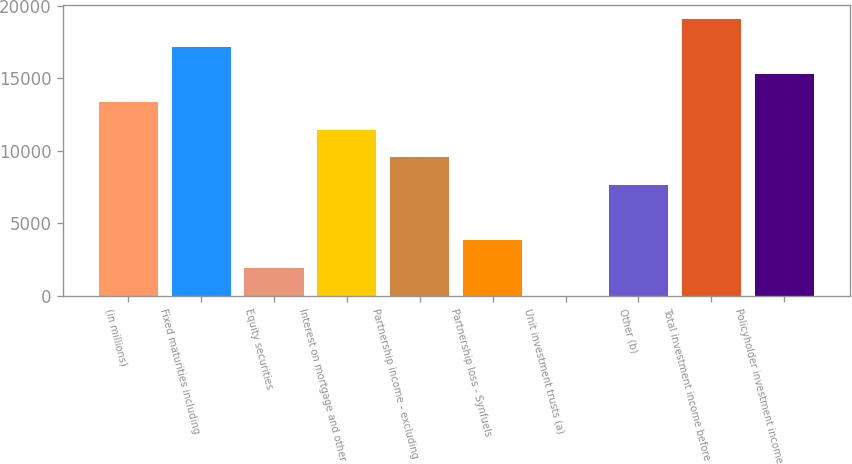Convert chart. <chart><loc_0><loc_0><loc_500><loc_500><bar_chart><fcel>(in millions)<fcel>Fixed maturities including<fcel>Equity securities<fcel>Interest on mortgage and other<fcel>Partnership income - excluding<fcel>Partnership loss - Synfuels<fcel>Unit investment trusts (a)<fcel>Other (b)<fcel>Total investment income before<fcel>Policyholder investment income<nl><fcel>13347.4<fcel>17159.8<fcel>1910.2<fcel>11441.2<fcel>9535<fcel>3816.4<fcel>4<fcel>7628.8<fcel>19066<fcel>15253.6<nl></chart> 